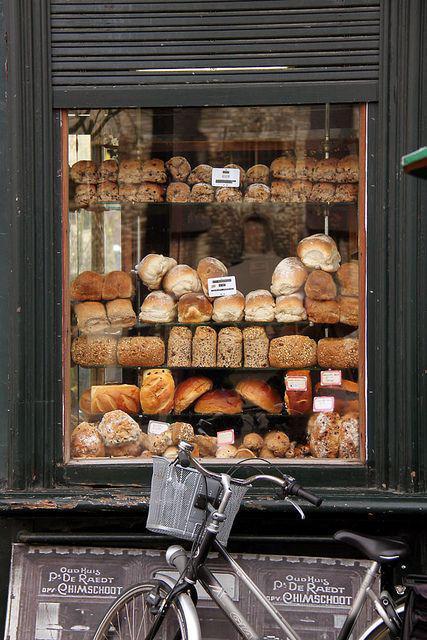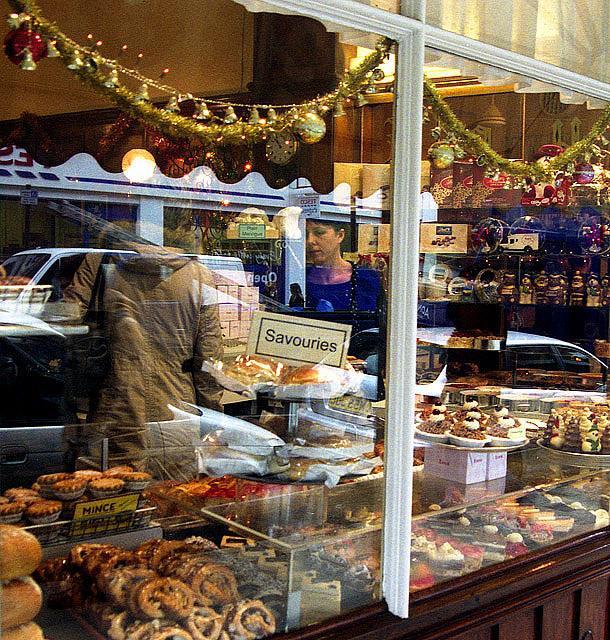The first image is the image on the left, the second image is the image on the right. Considering the images on both sides, is "The left image shows tiered shelves of baked goods behind glass, with white cards above some items facing the glass." valid? Answer yes or no. Yes. The first image is the image on the left, the second image is the image on the right. Analyze the images presented: Is the assertion "Two bakery windows show the reflection of at least one person." valid? Answer yes or no. Yes. 